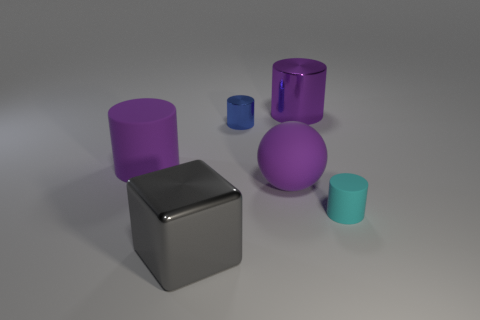Subtract all cyan balls. How many purple cylinders are left? 2 Subtract all blue cylinders. How many cylinders are left? 3 Subtract all small rubber cylinders. How many cylinders are left? 3 Subtract all brown cylinders. Subtract all yellow blocks. How many cylinders are left? 4 Add 3 brown rubber cylinders. How many objects exist? 9 Subtract all spheres. How many objects are left? 5 Subtract all tiny gray rubber blocks. Subtract all large shiny blocks. How many objects are left? 5 Add 3 metallic cylinders. How many metallic cylinders are left? 5 Add 1 matte spheres. How many matte spheres exist? 2 Subtract 0 green cylinders. How many objects are left? 6 